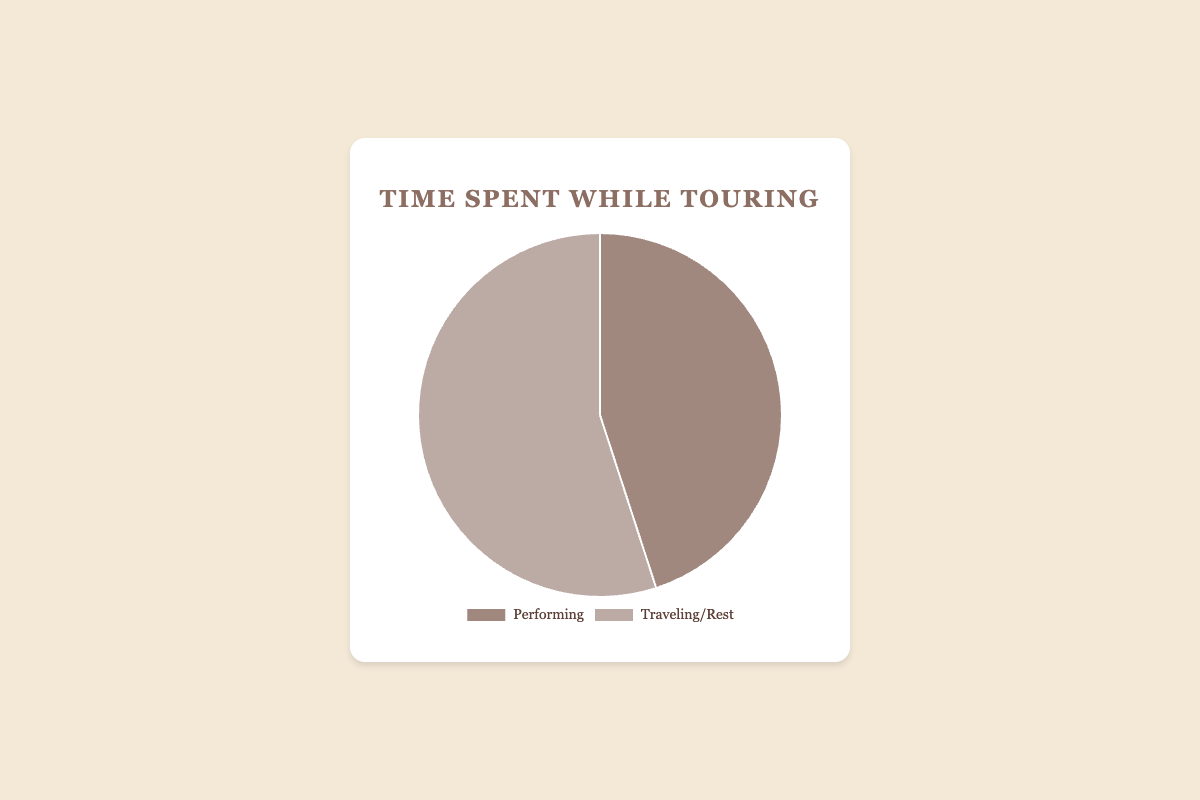What percentage of time is spent performing? The figure shows that 45% of the time is spent on performing.
Answer: 45% What percentage more time is spent traveling/resting compared to performing? Time spent traveling/resting is 55%, and performing is 45%. The difference in percentage is 55% - 45% = 10%.
Answer: 10% Which activity takes up more time? The figure shows that traveling/resting takes up 55%, which is more than the 45% spent performing.
Answer: Traveling/Rest What is the total percentage of time spent on all activities? The total percentage of time is the sum of the percentages spent performing and traveling/resting: 45% + 55% = 100%.
Answer: 100% If the total time spent on activities is 100 hours, how many hours are spent performing? 45% of the total time is spent performing. 45% of 100 hours is 0.45 × 100 = 45 hours.
Answer: 45 hours How would you describe the balance between performing and traveling/resting visually? The pie chart shows that the slice representing traveling/resting is larger than the slice for performing, indicating more time is spent traveling/resting.
Answer: More time is spent traveling/resting Is there an equal balance between performing and traveling/resting? The percentages are 45% for performing and 55% for traveling/resting, indicating there is not an equal balance. Traveling/resting takes up a larger portion.
Answer: No By how much does the time spent on traveling/resting exceed the time spent performing as a percentage? Time spent on traveling/resting is 55% and performing is 45%. The time spent traveling/resting exceeds performing by 55% - 45% = 10%.
Answer: 10% Which color in the pie chart represents the time spent performing? From the description, performing is represented by a color that contrasts with the color used for traveling/resting. The specific color is associated with performing.
Answer: The darker brown/tan color If the performer decides to increase the time spent performing by 5%, what will be the new percentage of time spent on traveling/resting? Increasing the time spent performing by 5% makes it 50%. Since the total must be 100%, the new percentage for traveling/resting would be 100% - 50% = 50%.
Answer: 50% 